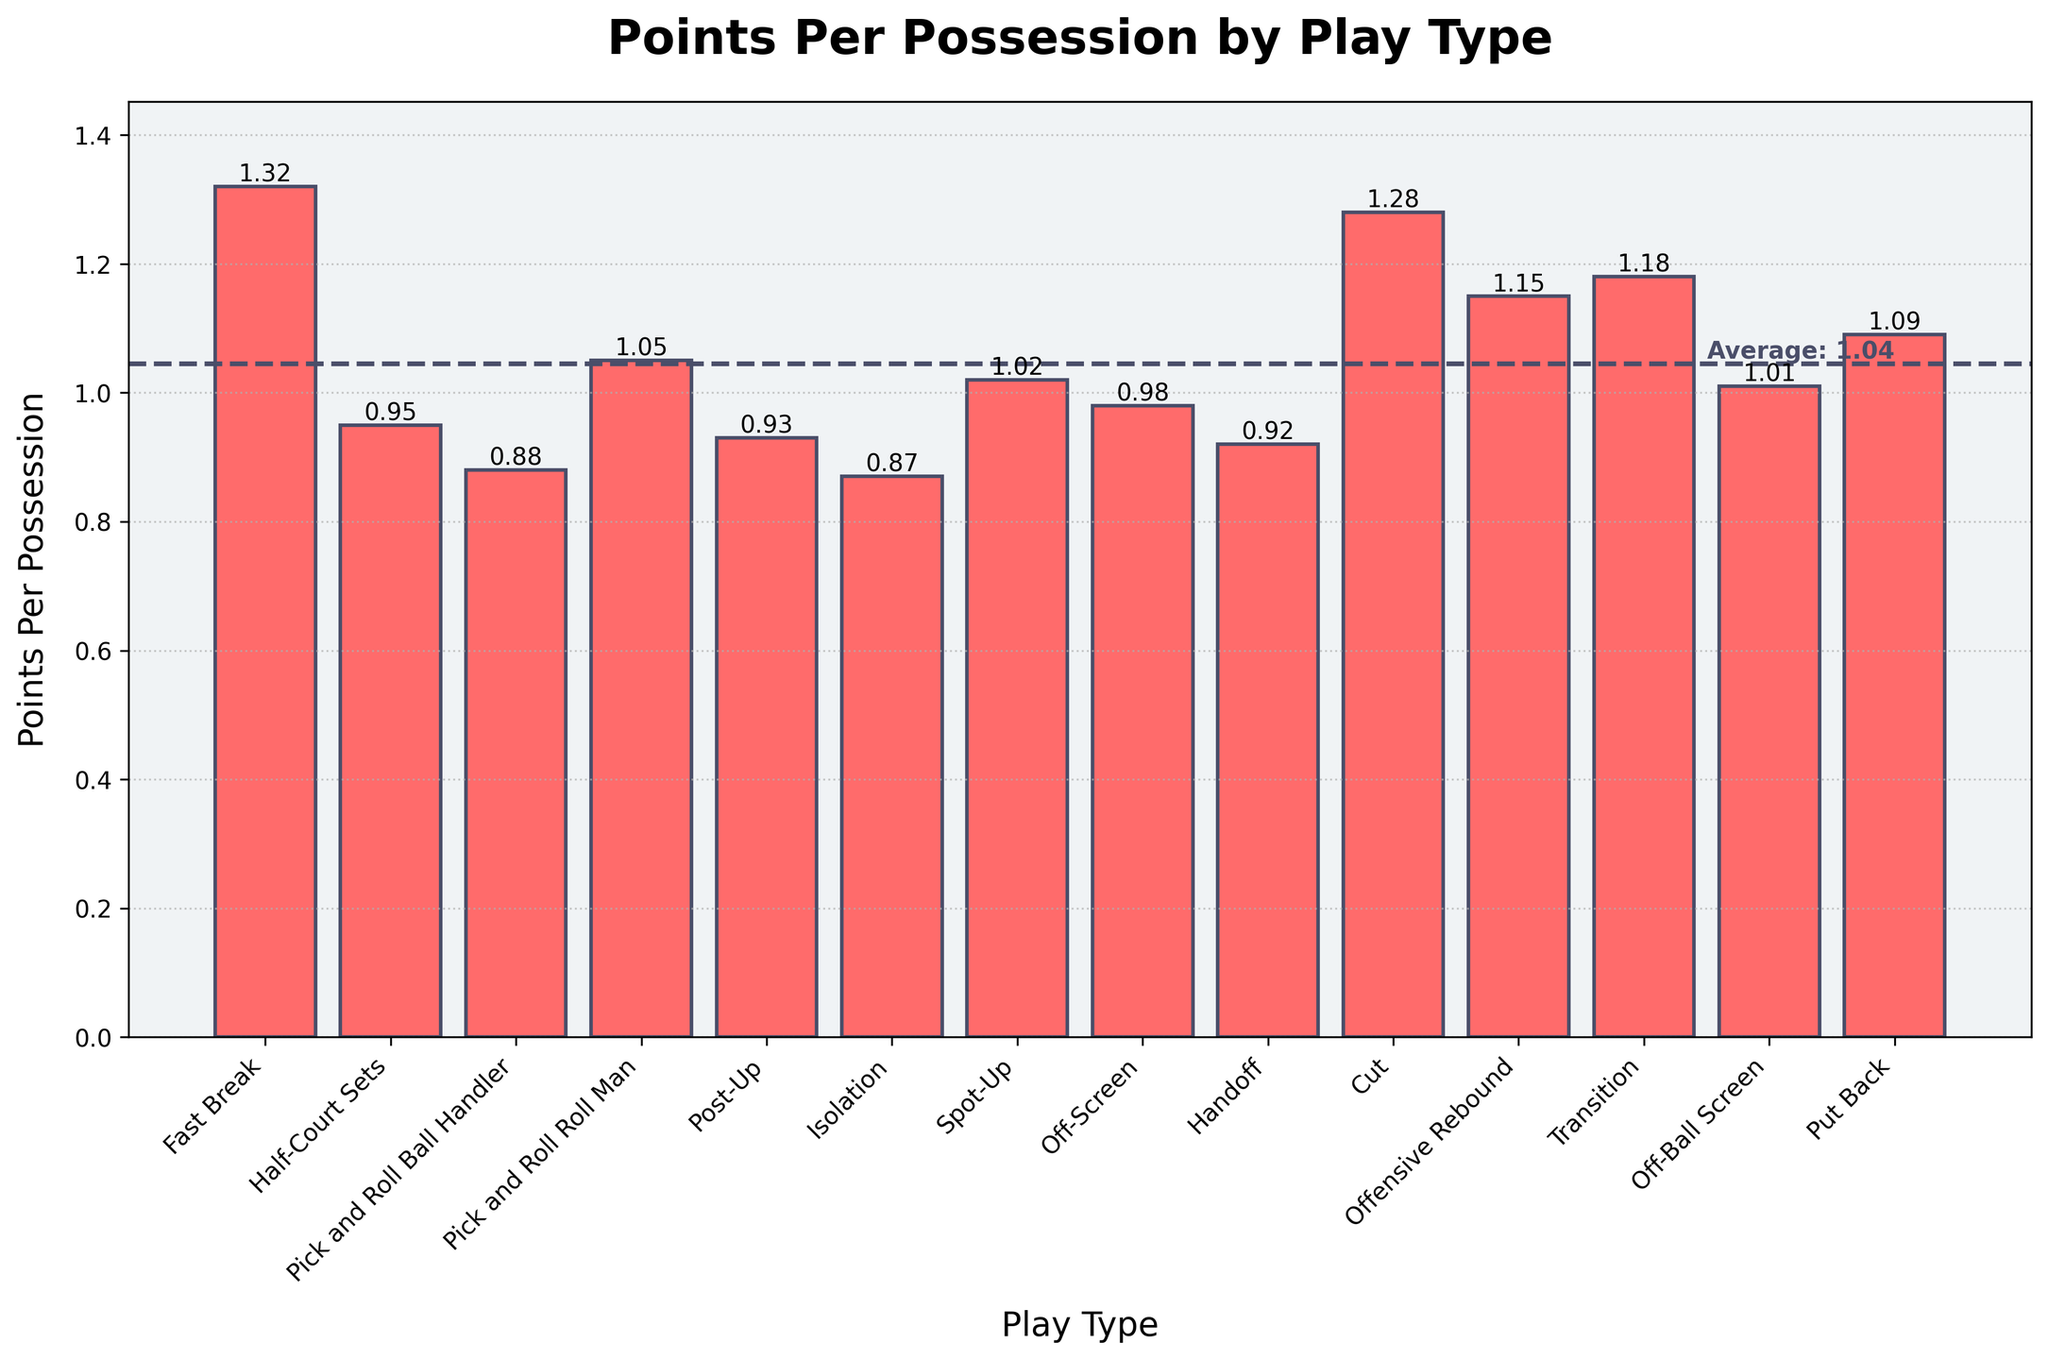what is the average points per possession across all play types? To calculate the average points per possession, sum up the points per possession for all play types and divide by the number of play types. The sum is (1.32 + 0.95 + 0.88 + 1.05 + 0.93 + 0.87 + 1.02 + 0.98 + 0.92 + 1.28 + 1.15 + 1.18 + 1.01 + 1.09) = 15.63. There are 14 play types, so the average is 15.63 / 14 ≈ 1.12
Answer: 1.12 which play type has the highest points per possession? By looking at the height of the bars, we see that the "Fast Break" bar is the tallest. Therefore, the Fast Break play type has the highest points per possession
Answer: Fast Break how does the points per possession for Isolation compare to that for Transition? Compare the bar heights for Isolation and Transition. Isolation has 0.87 points per possession, while Transition has 1.18 points per possession. Transition has a higher points per possession than Isolation
Answer: Transition is higher is the points per possession for Post-Up above or below average? First, calculate the average points per possession, which is 1.12. The points per possession for Post-Up is 0.93, which is below the average
Answer: Below which play types have points per possession between 1.0 and 1.2? Identify the bars that fall within the height range corresponding to 1.0 and 1.2. These play types are Spot-Up (1.02), Off-Screen (0.98), Offensive Rebound (1.15), Transition (1.18), Off-Ball Screen (1.01), Put Back (1.09)
Answer: Spot-Up, Offensive Rebound, Transition, Off-Ball Screen, Put Back what is the difference in points per possession between Pick and Roll Ball Handler and Pick and Roll Roll Man? The points per possession for Pick and Roll Ball Handler is 0.88, and for Pick and Roll Roll Man is 1.05. The difference is 1.05 - 0.88 = 0.17
Answer: 0.17 are there more play types scoring above or below 1.0 points per possession? Count the number of bars above 1.0 points per possession and below 1.0 points per possession. Above 1.0: Fast Break, Pick and Roll Roll Man, Spot-Up, Offensive Rebound, Transition, Cut, Off-Ball Screen, Put Back (8 play types). Below 1.0: Half-Court Sets, Pick and Roll Ball Handler, Post-Up, Isolation, Off-Screen, Handoff (6 play types)
Answer: More above what is the median value of points per possession across all play types? Arrange the points per possession values in ascending order: 0.87, 0.88, 0.92, 0.93, 0.95, 0.98, 1.01, 1.02, 1.05, 1.09, 1.15, 1.18, 1.28, 1.32. The median is the average of the 7th and 8th values. (1.01 + 1.02) / 2 = 1.015
Answer: 1.015 